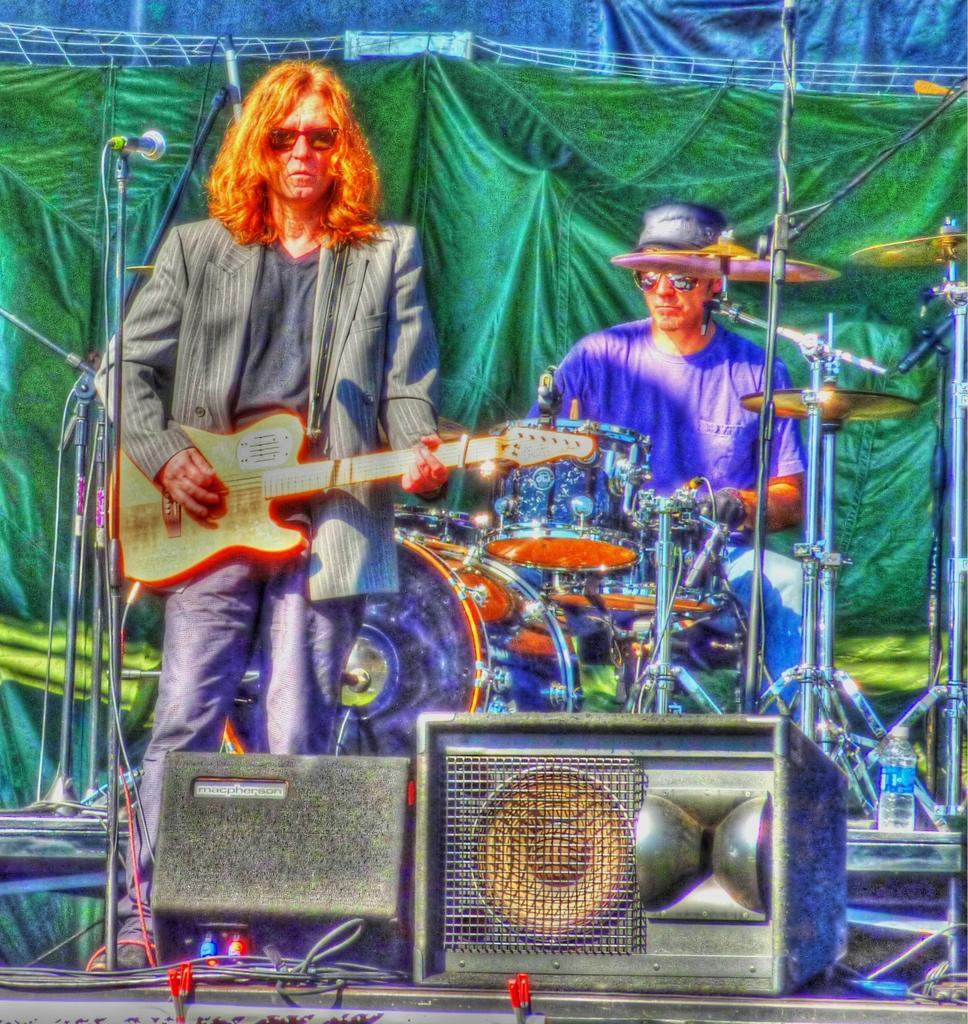How would you summarize this image in a sentence or two? This person is playing a guitar. Another person is playing this musical instrument. Here we can see speakers and mics. Background there is a curtains. This is bottle. 